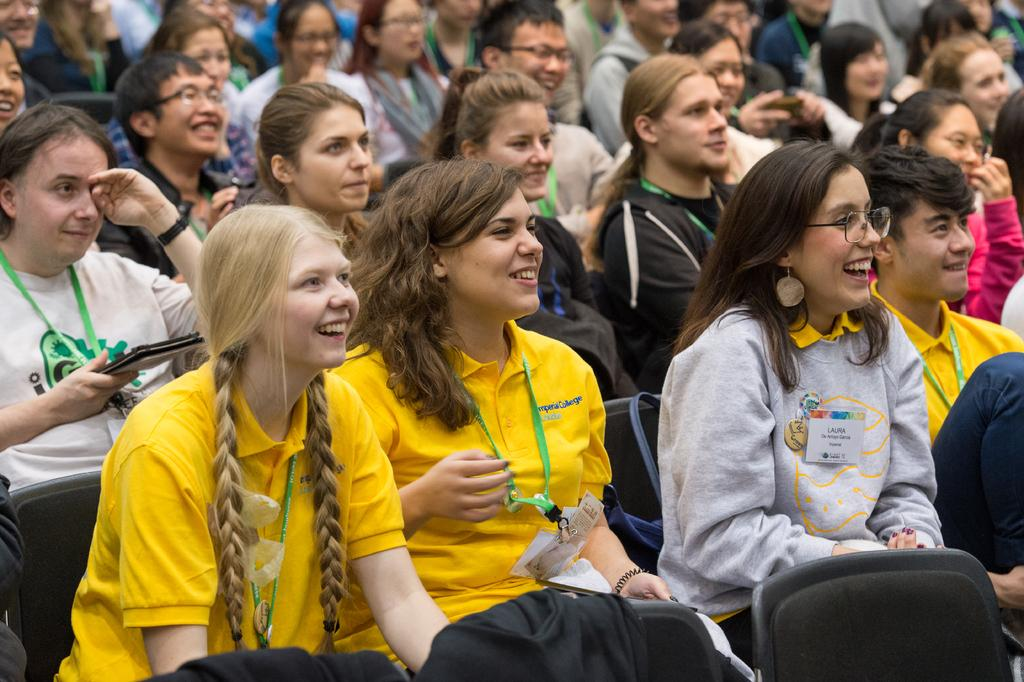What are the people in the image doing? The people in the image are sitting on chairs. Can you describe any accessories or items that the people are wearing or holding? Some of the people are wearing ID cards and spectacles. What expressions do some of the people have in the image? Some of the people are smiling. What type of texture can be seen on the furniture in the image? There is no furniture present in the image; it only shows people sitting on chairs. 